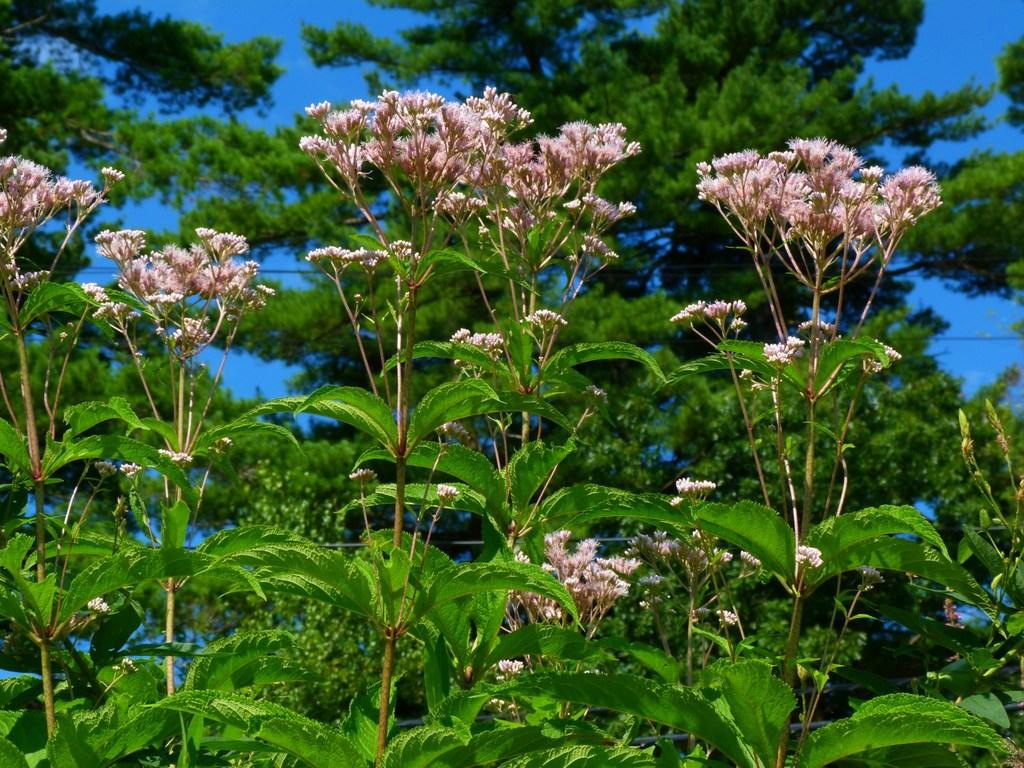What color are the flowers in the image? The flowers in the image are pink. What are the flowers attached to? The flowers are on plants. What can be seen in the background of the image? There are trees and the sky visible in the background of the image. How does the process of digestion occur in the image? The process of digestion is not depicted in the image, as it features flowers on plants with a background of trees and the sky. 